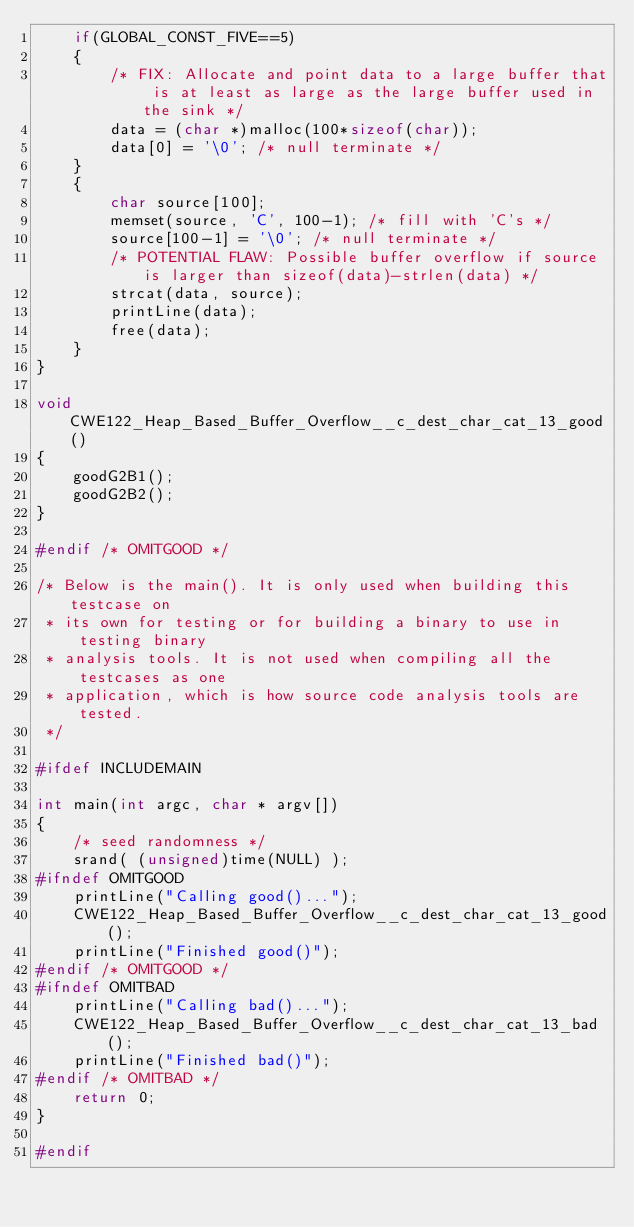Convert code to text. <code><loc_0><loc_0><loc_500><loc_500><_C_>    if(GLOBAL_CONST_FIVE==5)
    {
        /* FIX: Allocate and point data to a large buffer that is at least as large as the large buffer used in the sink */
        data = (char *)malloc(100*sizeof(char));
        data[0] = '\0'; /* null terminate */
    }
    {
        char source[100];
        memset(source, 'C', 100-1); /* fill with 'C's */
        source[100-1] = '\0'; /* null terminate */
        /* POTENTIAL FLAW: Possible buffer overflow if source is larger than sizeof(data)-strlen(data) */
        strcat(data, source);
        printLine(data);
        free(data);
    }
}

void CWE122_Heap_Based_Buffer_Overflow__c_dest_char_cat_13_good()
{
    goodG2B1();
    goodG2B2();
}

#endif /* OMITGOOD */

/* Below is the main(). It is only used when building this testcase on
 * its own for testing or for building a binary to use in testing binary
 * analysis tools. It is not used when compiling all the testcases as one
 * application, which is how source code analysis tools are tested.
 */

#ifdef INCLUDEMAIN

int main(int argc, char * argv[])
{
    /* seed randomness */
    srand( (unsigned)time(NULL) );
#ifndef OMITGOOD
    printLine("Calling good()...");
    CWE122_Heap_Based_Buffer_Overflow__c_dest_char_cat_13_good();
    printLine("Finished good()");
#endif /* OMITGOOD */
#ifndef OMITBAD
    printLine("Calling bad()...");
    CWE122_Heap_Based_Buffer_Overflow__c_dest_char_cat_13_bad();
    printLine("Finished bad()");
#endif /* OMITBAD */
    return 0;
}

#endif
</code> 